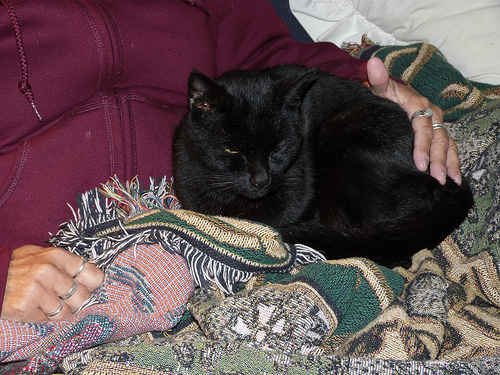<image>
Can you confirm if the cat is on the person? Yes. Looking at the image, I can see the cat is positioned on top of the person, with the person providing support. 